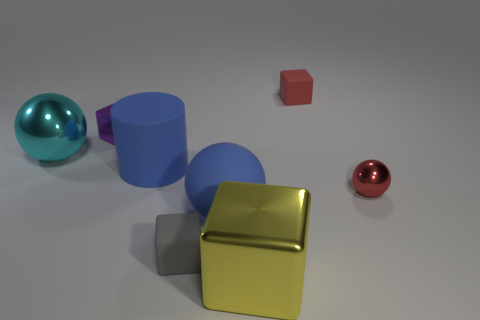Add 2 small metal blocks. How many objects exist? 10 Subtract all large cyan spheres. How many spheres are left? 2 Subtract all cylinders. How many objects are left? 7 Subtract 3 spheres. How many spheres are left? 0 Subtract all small red metallic objects. Subtract all big blue rubber cylinders. How many objects are left? 6 Add 1 red cubes. How many red cubes are left? 2 Add 6 large shiny objects. How many large shiny objects exist? 8 Subtract all blue balls. How many balls are left? 2 Subtract 0 green blocks. How many objects are left? 8 Subtract all yellow balls. Subtract all red cylinders. How many balls are left? 3 